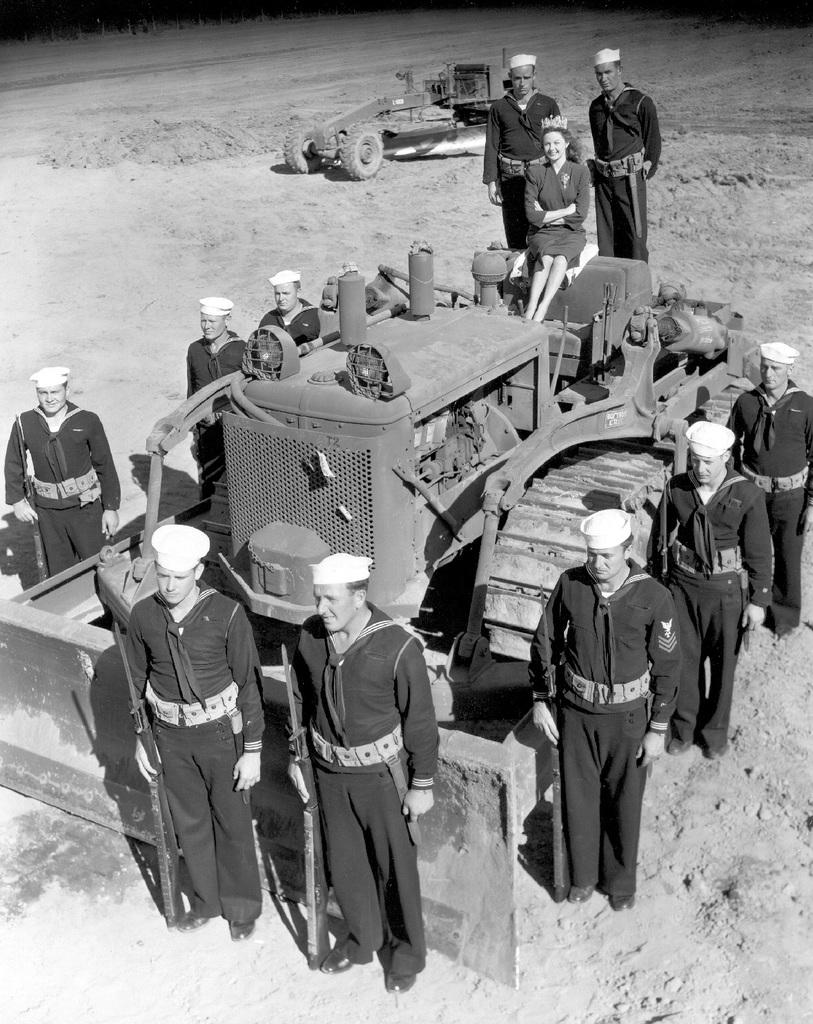What are the people in the image doing? The people in the image are standing and holding guns. What else can be seen in the image besides the people? There are vehicles visible in the image. What color is the sock that the person in the image is wearing? There is no sock visible in the image. How many halls are present in the image? There are no halls present in the image. 